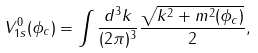<formula> <loc_0><loc_0><loc_500><loc_500>V ^ { 0 } _ { 1 s } ( \phi _ { c } ) = \int \frac { d ^ { 3 } k } { ( 2 \pi ) ^ { 3 } } \frac { \sqrt { k ^ { 2 } + m ^ { 2 } ( \phi _ { c } ) } } { 2 } ,</formula> 